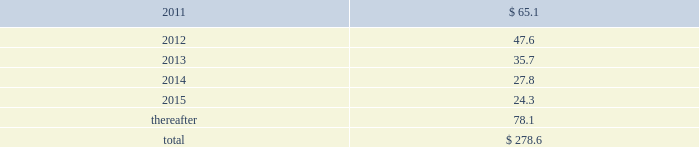Future minimum operating lease payments for leases with remaining terms greater than one year for each of the years in the five years ending december 31 , 2015 , and thereafter in the aggregate , are as follows ( in millions ) : .
In addition , the company has operating lease commitments relating to office equipment and computer hardware with annual lease payments of approximately $ 16.3 million per year which renew on a short-term basis .
Rent expense incurred under all operating leases during the years ended december 31 , 2010 , 2009 and 2008 was $ 116.1 million , $ 100.2 million and $ 117.0 million , respectively .
Included in discontinued operations in the consolidated statements of earnings was rent expense of $ 2.0 million , $ 1.8 million and $ 17.0 million for the years ended december 31 , 2010 , 2009 and 2008 , respectively .
Data processing and maintenance services agreements .
The company has agreements with various vendors , which expire between 2011 and 2017 , for portions of its computer data processing operations and related functions .
The company 2019s estimated aggregate contractual obligation remaining under these agreements was approximately $ 554.3 million as of december 31 , 2010 .
However , this amount could be more or less depending on various factors such as the inflation rate , foreign exchange rates , the introduction of significant new technologies , or changes in the company 2019s data processing needs .
( 16 ) employee benefit plans stock purchase plan fis employees participate in an employee stock purchase plan ( espp ) .
Eligible employees may voluntarily purchase , at current market prices , shares of fis 2019 common stock through payroll deductions .
Pursuant to the espp , employees may contribute an amount between 3% ( 3 % ) and 15% ( 15 % ) of their base salary and certain commissions .
Shares purchased are allocated to employees based upon their contributions .
The company contributes varying matching amounts as specified in the espp .
The company recorded an expense of $ 14.3 million , $ 12.4 million and $ 14.3 million , respectively , for the years ended december 31 , 2010 , 2009 and 2008 , relating to the participation of fis employees in the espp .
Included in discontinued operations in the consolidated statements of earnings was expense of $ 0.1 million and $ 3.0 million for the years ended december 31 , 2009 and 2008 , respectively .
401 ( k ) profit sharing plan the company 2019s employees are covered by a qualified 401 ( k ) plan .
Eligible employees may contribute up to 40% ( 40 % ) of their pretax annual compensation , up to the amount allowed pursuant to the internal revenue code .
The company generally matches 50% ( 50 % ) of each dollar of employee contribution up to 6% ( 6 % ) of the employee 2019s total eligible compensation .
The company recorded expense of $ 23.1 million , $ 16.6 million and $ 18.5 million , respectively , for the years ended december 31 , 2010 , 2009 and 2008 , relating to the participation of fis employees in the 401 ( k ) plan .
Included in discontinued operations in the consolidated statements of earnings was expense of $ 0.1 million and $ 3.9 million for the years ended december 31 , 2009 and 2008 , respectively .
Fidelity national information services , inc .
And subsidiaries notes to consolidated financial statements 2014 ( continued ) %%transmsg*** transmitting job : g26369 pcn : 083000000 ***%%pcmsg|83 |00006|yes|no|03/28/2011 17:32|0|0|page is valid , no graphics -- color : n| .
What is the increase in rent expense from 2009 to 2010? 
Computations: ((116.1 - 100.2) / 100.2)
Answer: 0.15868. 